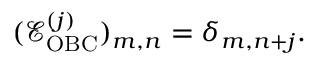<formula> <loc_0><loc_0><loc_500><loc_500>\begin{array} { r } { ( \mathcal { E } _ { O B C } ^ { ( j ) } ) _ { m , n } = \delta _ { m , n + j } . } \end{array}</formula> 